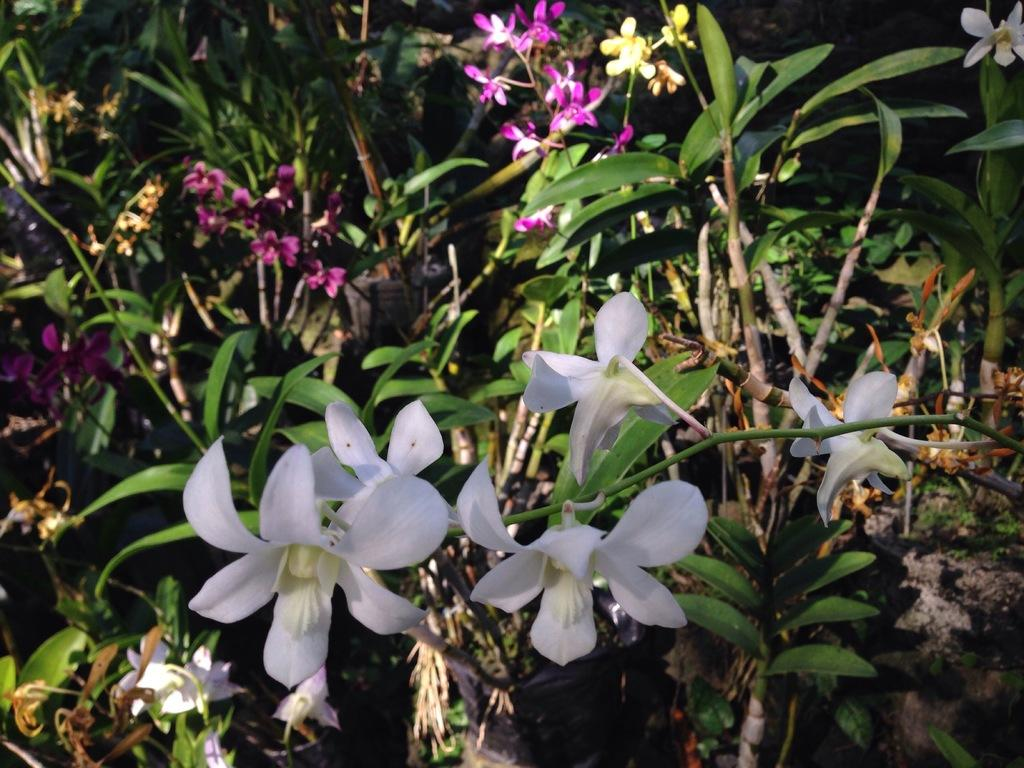What type of plant is visible in the image? The image features a plant with flowers. What colors can be seen on the flowers? The flowers are white and pink in color. What type of zinc is used to support the plant in the image? There is no zinc present in the image; the plant is supported by its own stem and leaves. 